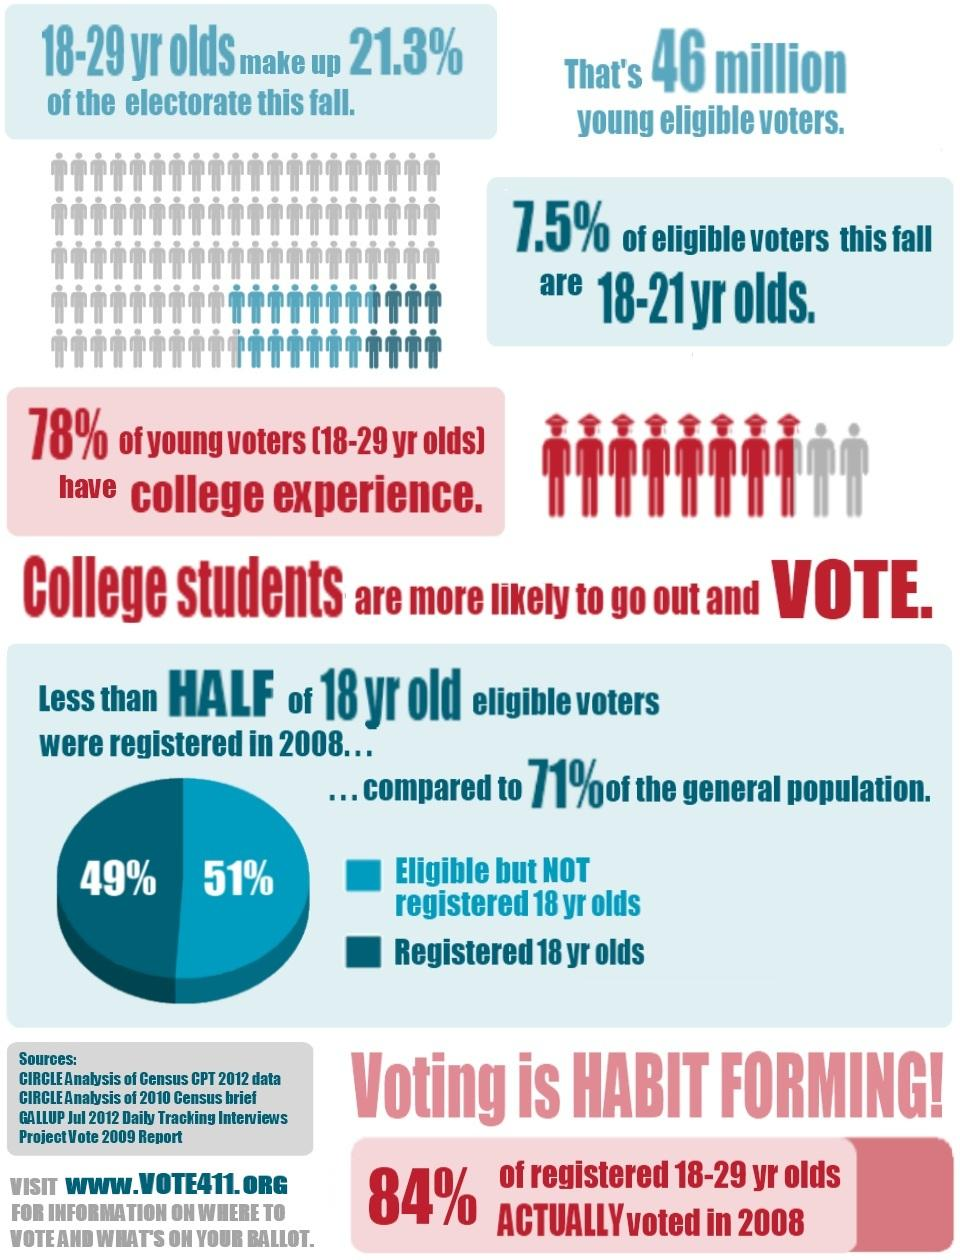Mention a couple of crucial points in this snapshot. According to the pie chart, 49% of registered voters are 18-year-olds. Four sources have been provided. 